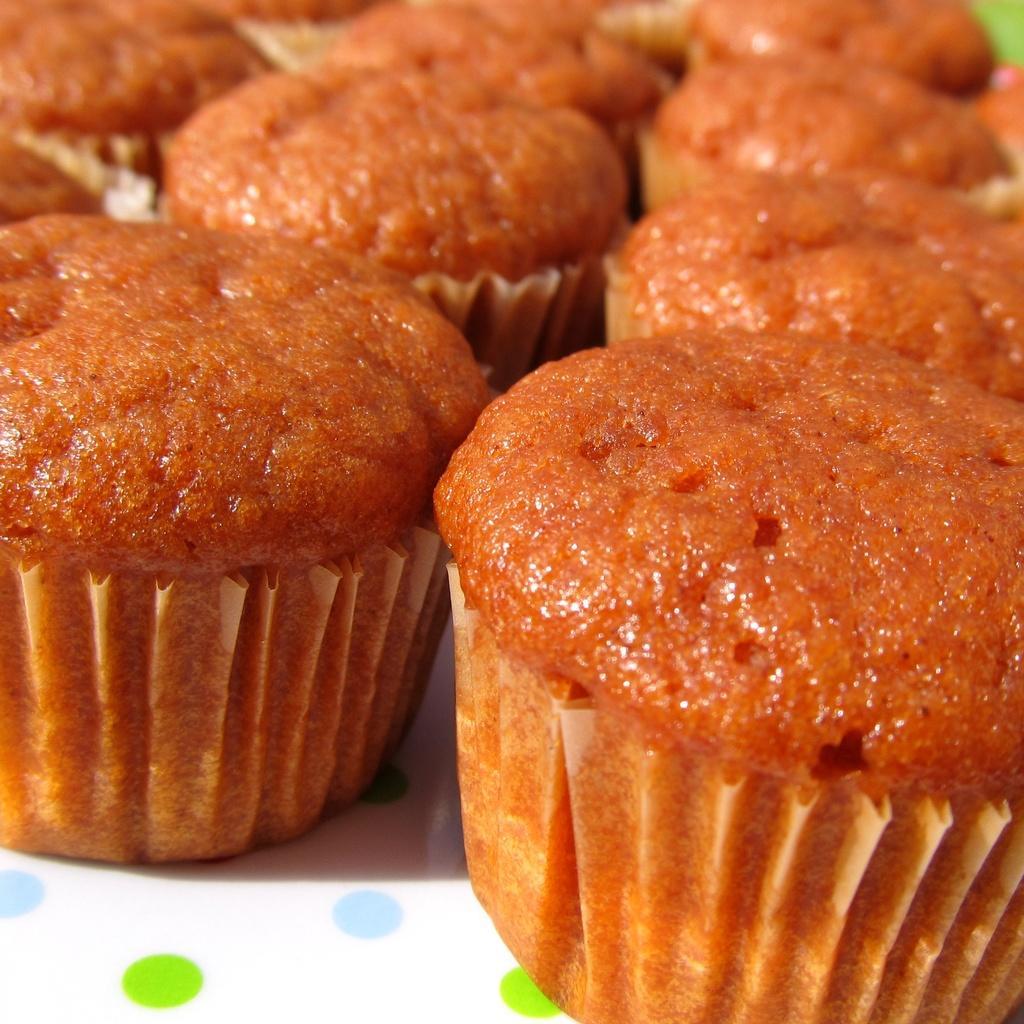Can you describe this image briefly? There are many brown cupcakes on a white surface. 